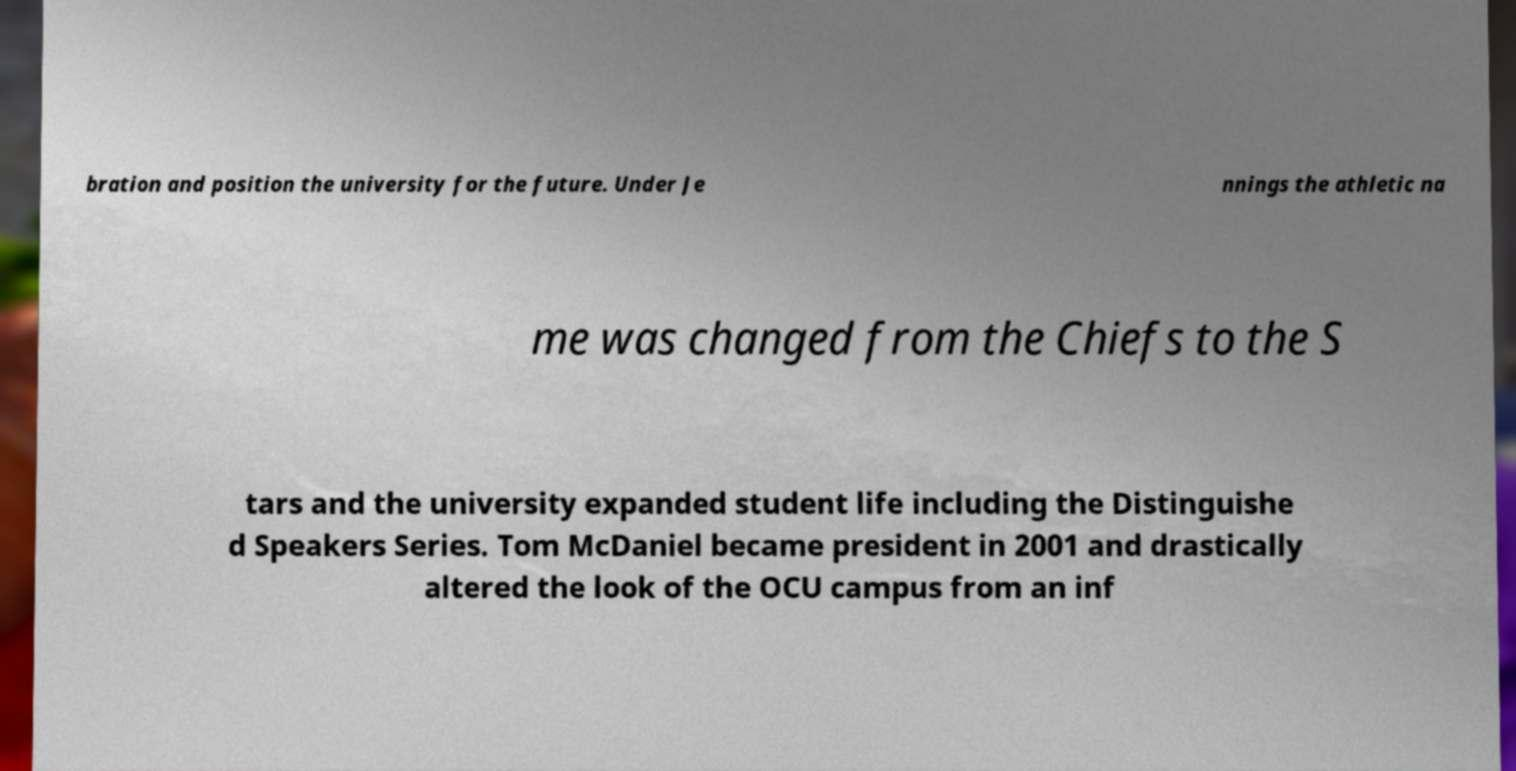Can you read and provide the text displayed in the image?This photo seems to have some interesting text. Can you extract and type it out for me? bration and position the university for the future. Under Je nnings the athletic na me was changed from the Chiefs to the S tars and the university expanded student life including the Distinguishe d Speakers Series. Tom McDaniel became president in 2001 and drastically altered the look of the OCU campus from an inf 